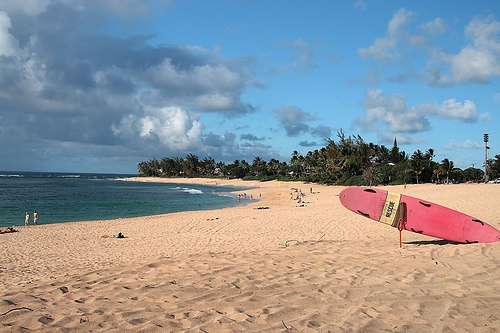Describe the objects in this image and their specific colors. I can see surfboard in darkgray, salmon, and tan tones, people in darkgray, black, gray, and salmon tones, people in darkgray, gray, black, and maroon tones, people in darkgray, gray, and tan tones, and people in darkgray, gray, and khaki tones in this image. 